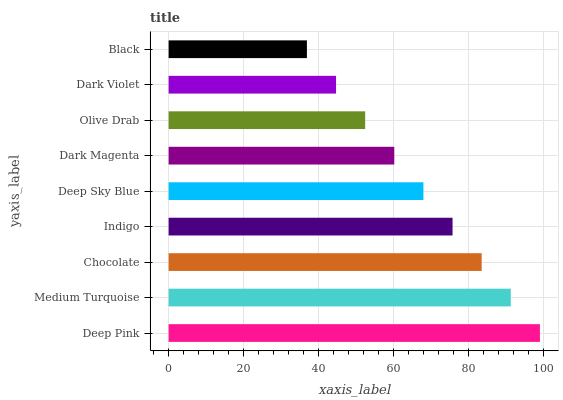Is Black the minimum?
Answer yes or no. Yes. Is Deep Pink the maximum?
Answer yes or no. Yes. Is Medium Turquoise the minimum?
Answer yes or no. No. Is Medium Turquoise the maximum?
Answer yes or no. No. Is Deep Pink greater than Medium Turquoise?
Answer yes or no. Yes. Is Medium Turquoise less than Deep Pink?
Answer yes or no. Yes. Is Medium Turquoise greater than Deep Pink?
Answer yes or no. No. Is Deep Pink less than Medium Turquoise?
Answer yes or no. No. Is Deep Sky Blue the high median?
Answer yes or no. Yes. Is Deep Sky Blue the low median?
Answer yes or no. Yes. Is Deep Pink the high median?
Answer yes or no. No. Is Medium Turquoise the low median?
Answer yes or no. No. 